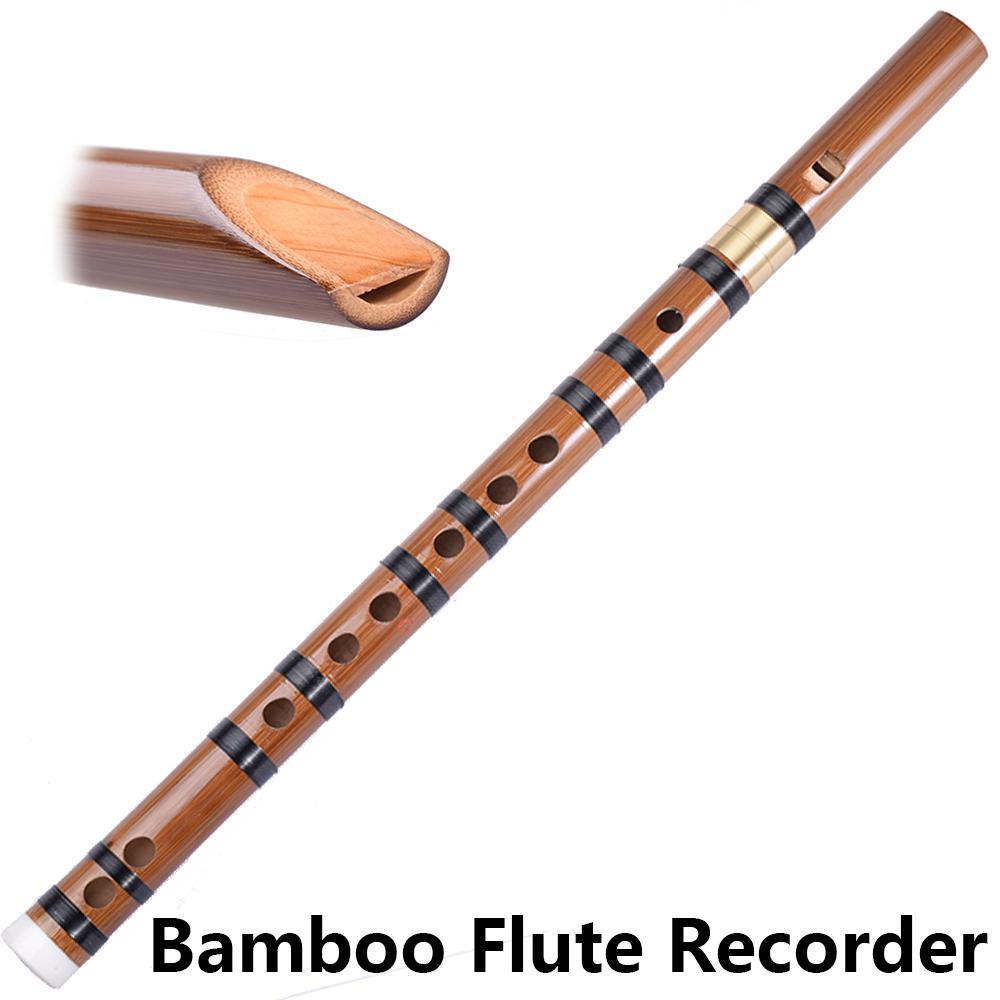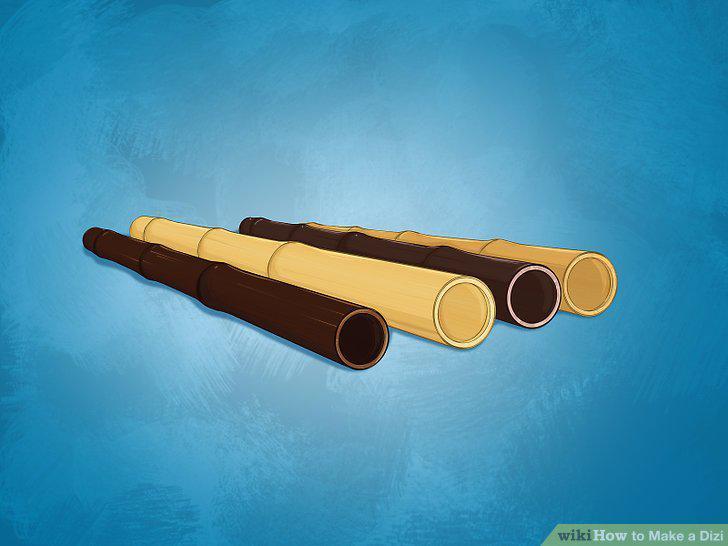The first image is the image on the left, the second image is the image on the right. Analyze the images presented: Is the assertion "The combined images contain exactly 5 pipe shapes with at least one flat end, and the images include at least one pipe shape perforated with holes on its side." valid? Answer yes or no. Yes. The first image is the image on the left, the second image is the image on the right. Examine the images to the left and right. Is the description "In at least one image there are two small flutes." accurate? Answer yes or no. No. 